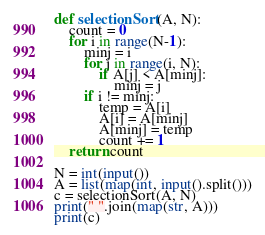<code> <loc_0><loc_0><loc_500><loc_500><_Python_>def selectionSort(A, N):
    count = 0
    for i in range(N-1):
        minj = i
        for j in range(i, N):
            if A[j] < A[minj]:
                minj = j
        if i != minj:
            temp = A[i]
            A[i] = A[minj]
            A[minj] = temp
            count += 1
    return count

N = int(input())
A = list(map(int, input().split()))
c = selectionSort(A, N)
print(" ".join(map(str, A)))
print(c)

</code> 